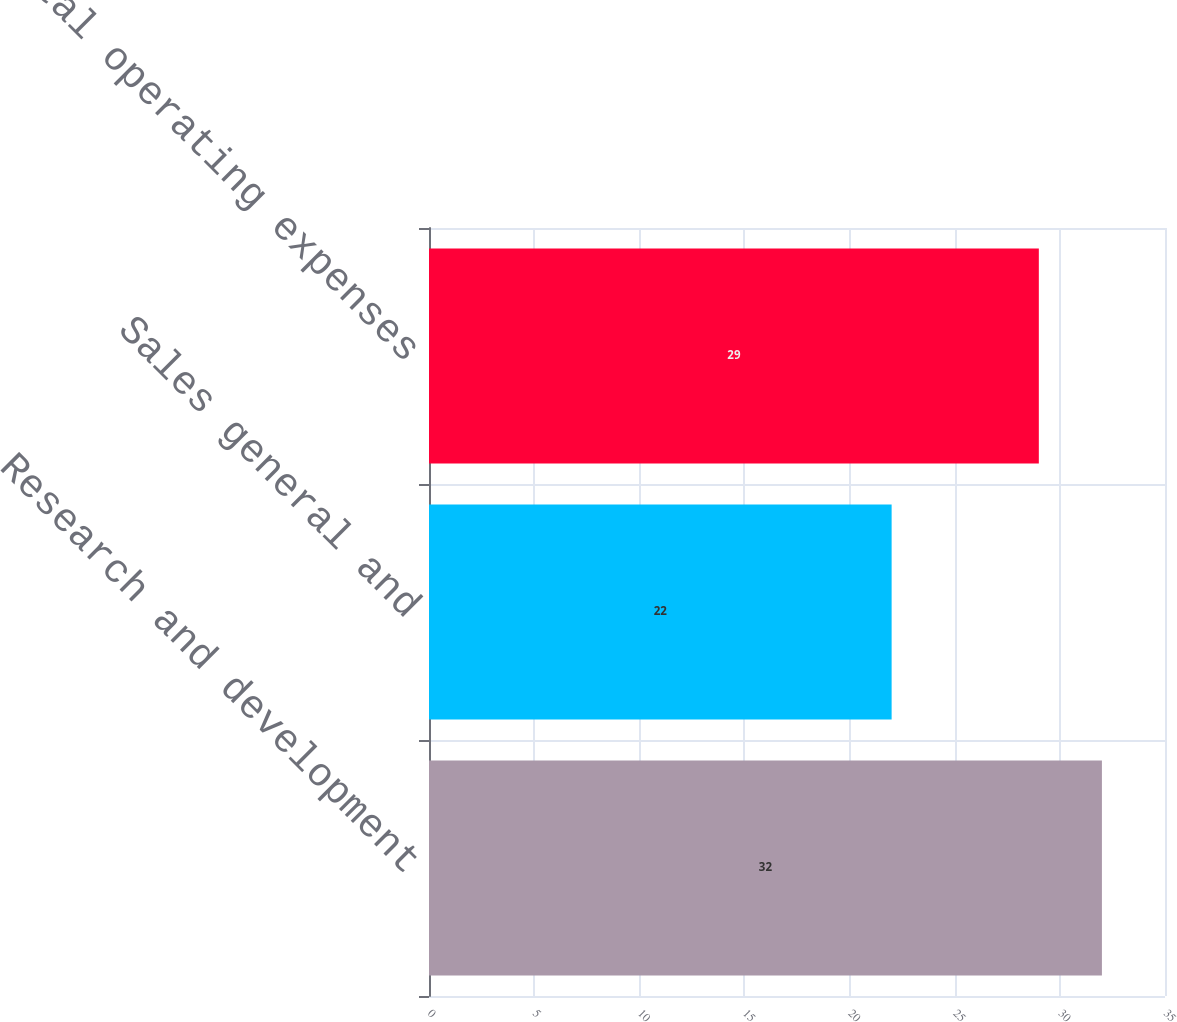<chart> <loc_0><loc_0><loc_500><loc_500><bar_chart><fcel>Research and development<fcel>Sales general and<fcel>Total operating expenses<nl><fcel>32<fcel>22<fcel>29<nl></chart> 